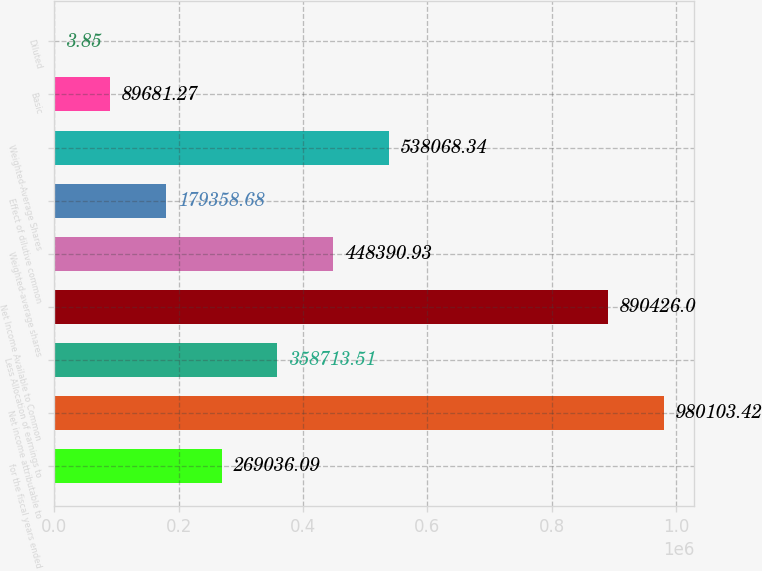<chart> <loc_0><loc_0><loc_500><loc_500><bar_chart><fcel>for the fiscal years ended<fcel>Net income attributable to<fcel>Less Allocation of earnings to<fcel>Net Income Available to Common<fcel>Weighted-average shares<fcel>Effect of dilutive common<fcel>Weighted-Average Shares<fcel>Basic<fcel>Diluted<nl><fcel>269036<fcel>980103<fcel>358714<fcel>890426<fcel>448391<fcel>179359<fcel>538068<fcel>89681.3<fcel>3.85<nl></chart> 